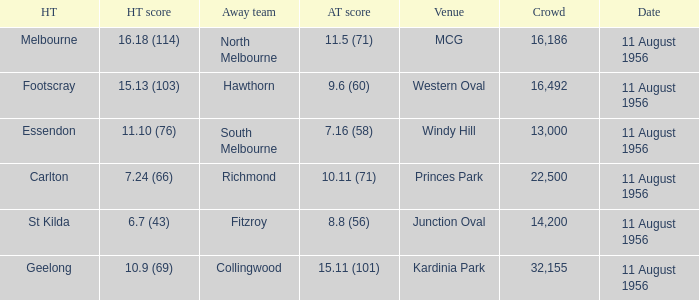What home team has a score of 16.18 (114)? Melbourne. 